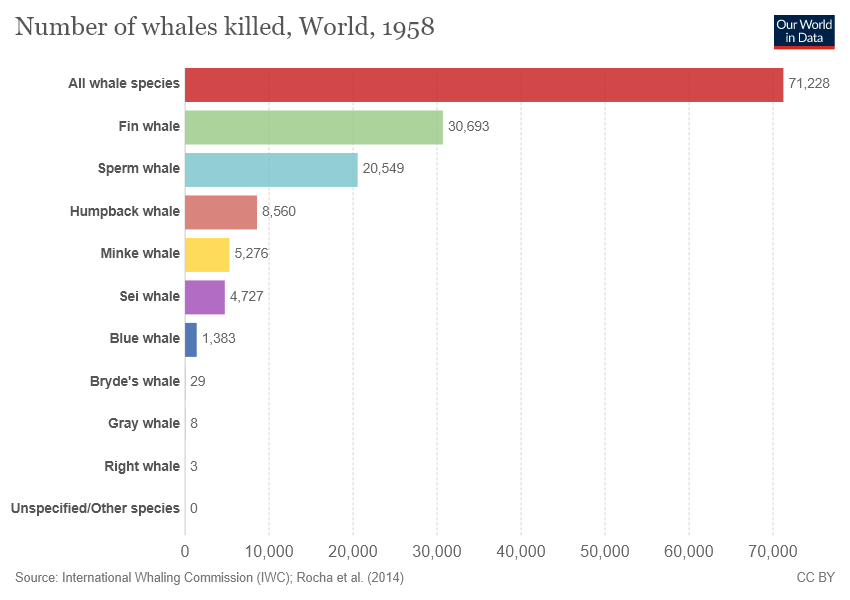Point out several critical features in this image. In 1958, an estimated 20,549 Sperm whales were killed globally. The sum total of Fin whale and Sperm whale killed is more than 50,000. 